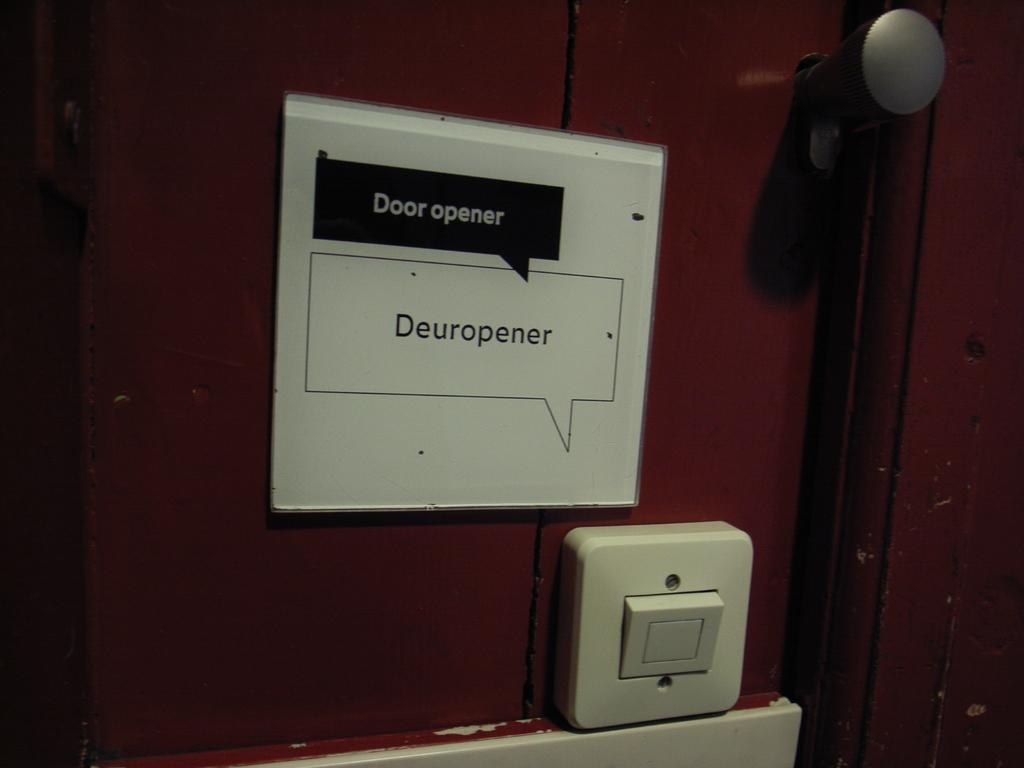Provide a one-sentence caption for the provided image. A door with a sign posted above a button on the door that says Door opener above a button. 